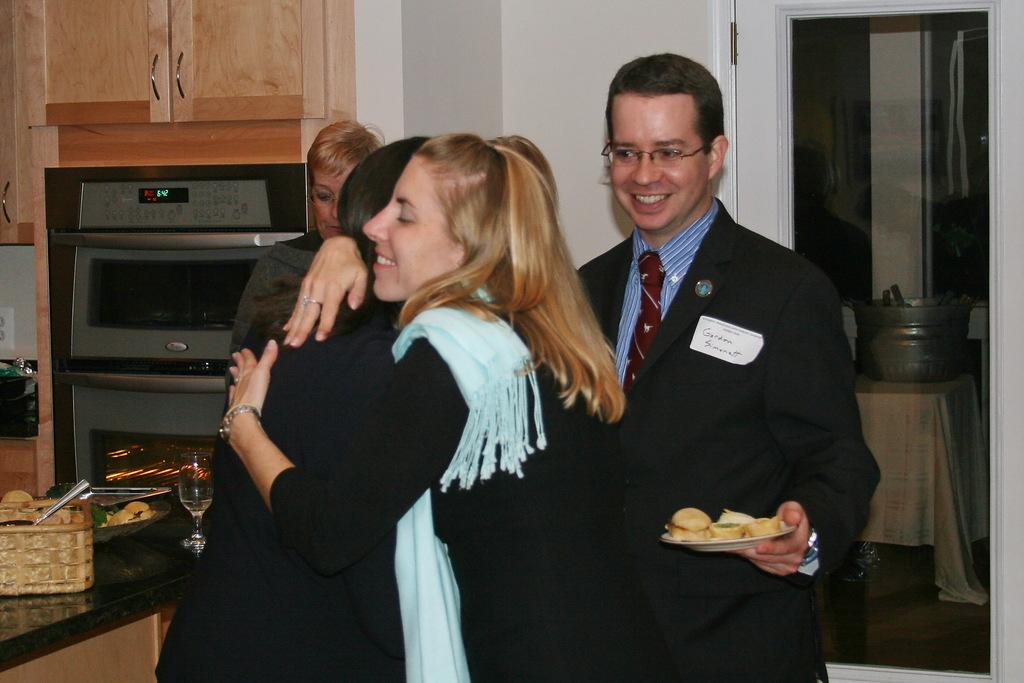<image>
Write a terse but informative summary of the picture. a man with name sticker Gordon Simonett looks at two women hugging 